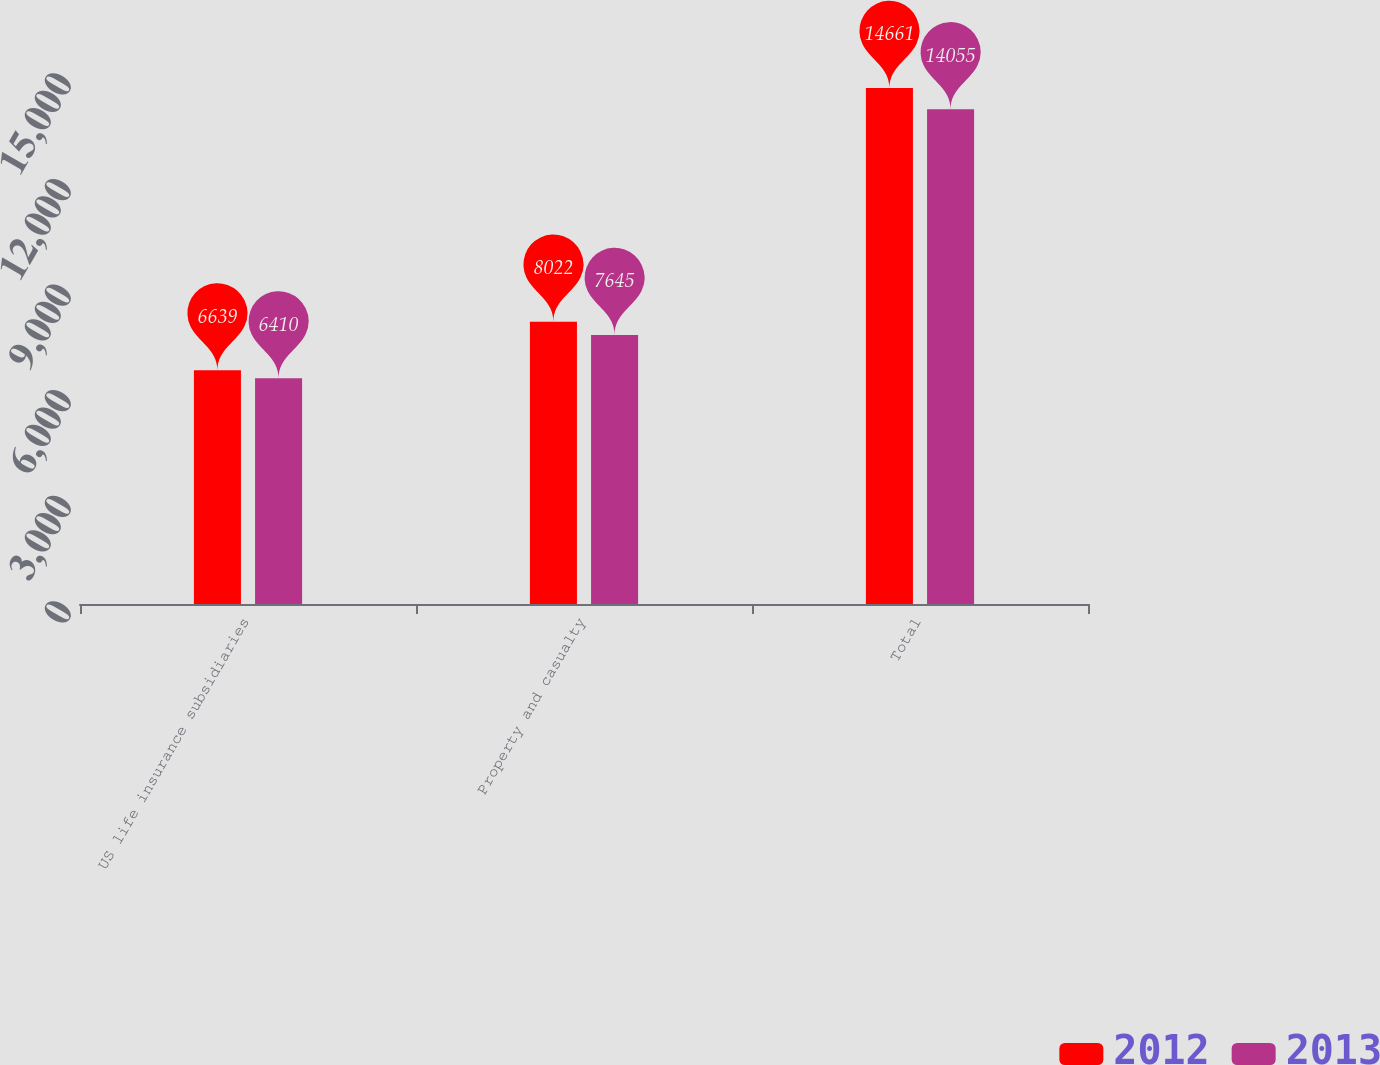Convert chart to OTSL. <chart><loc_0><loc_0><loc_500><loc_500><stacked_bar_chart><ecel><fcel>US life insurance subsidiaries<fcel>Property and casualty<fcel>Total<nl><fcel>2012<fcel>6639<fcel>8022<fcel>14661<nl><fcel>2013<fcel>6410<fcel>7645<fcel>14055<nl></chart> 